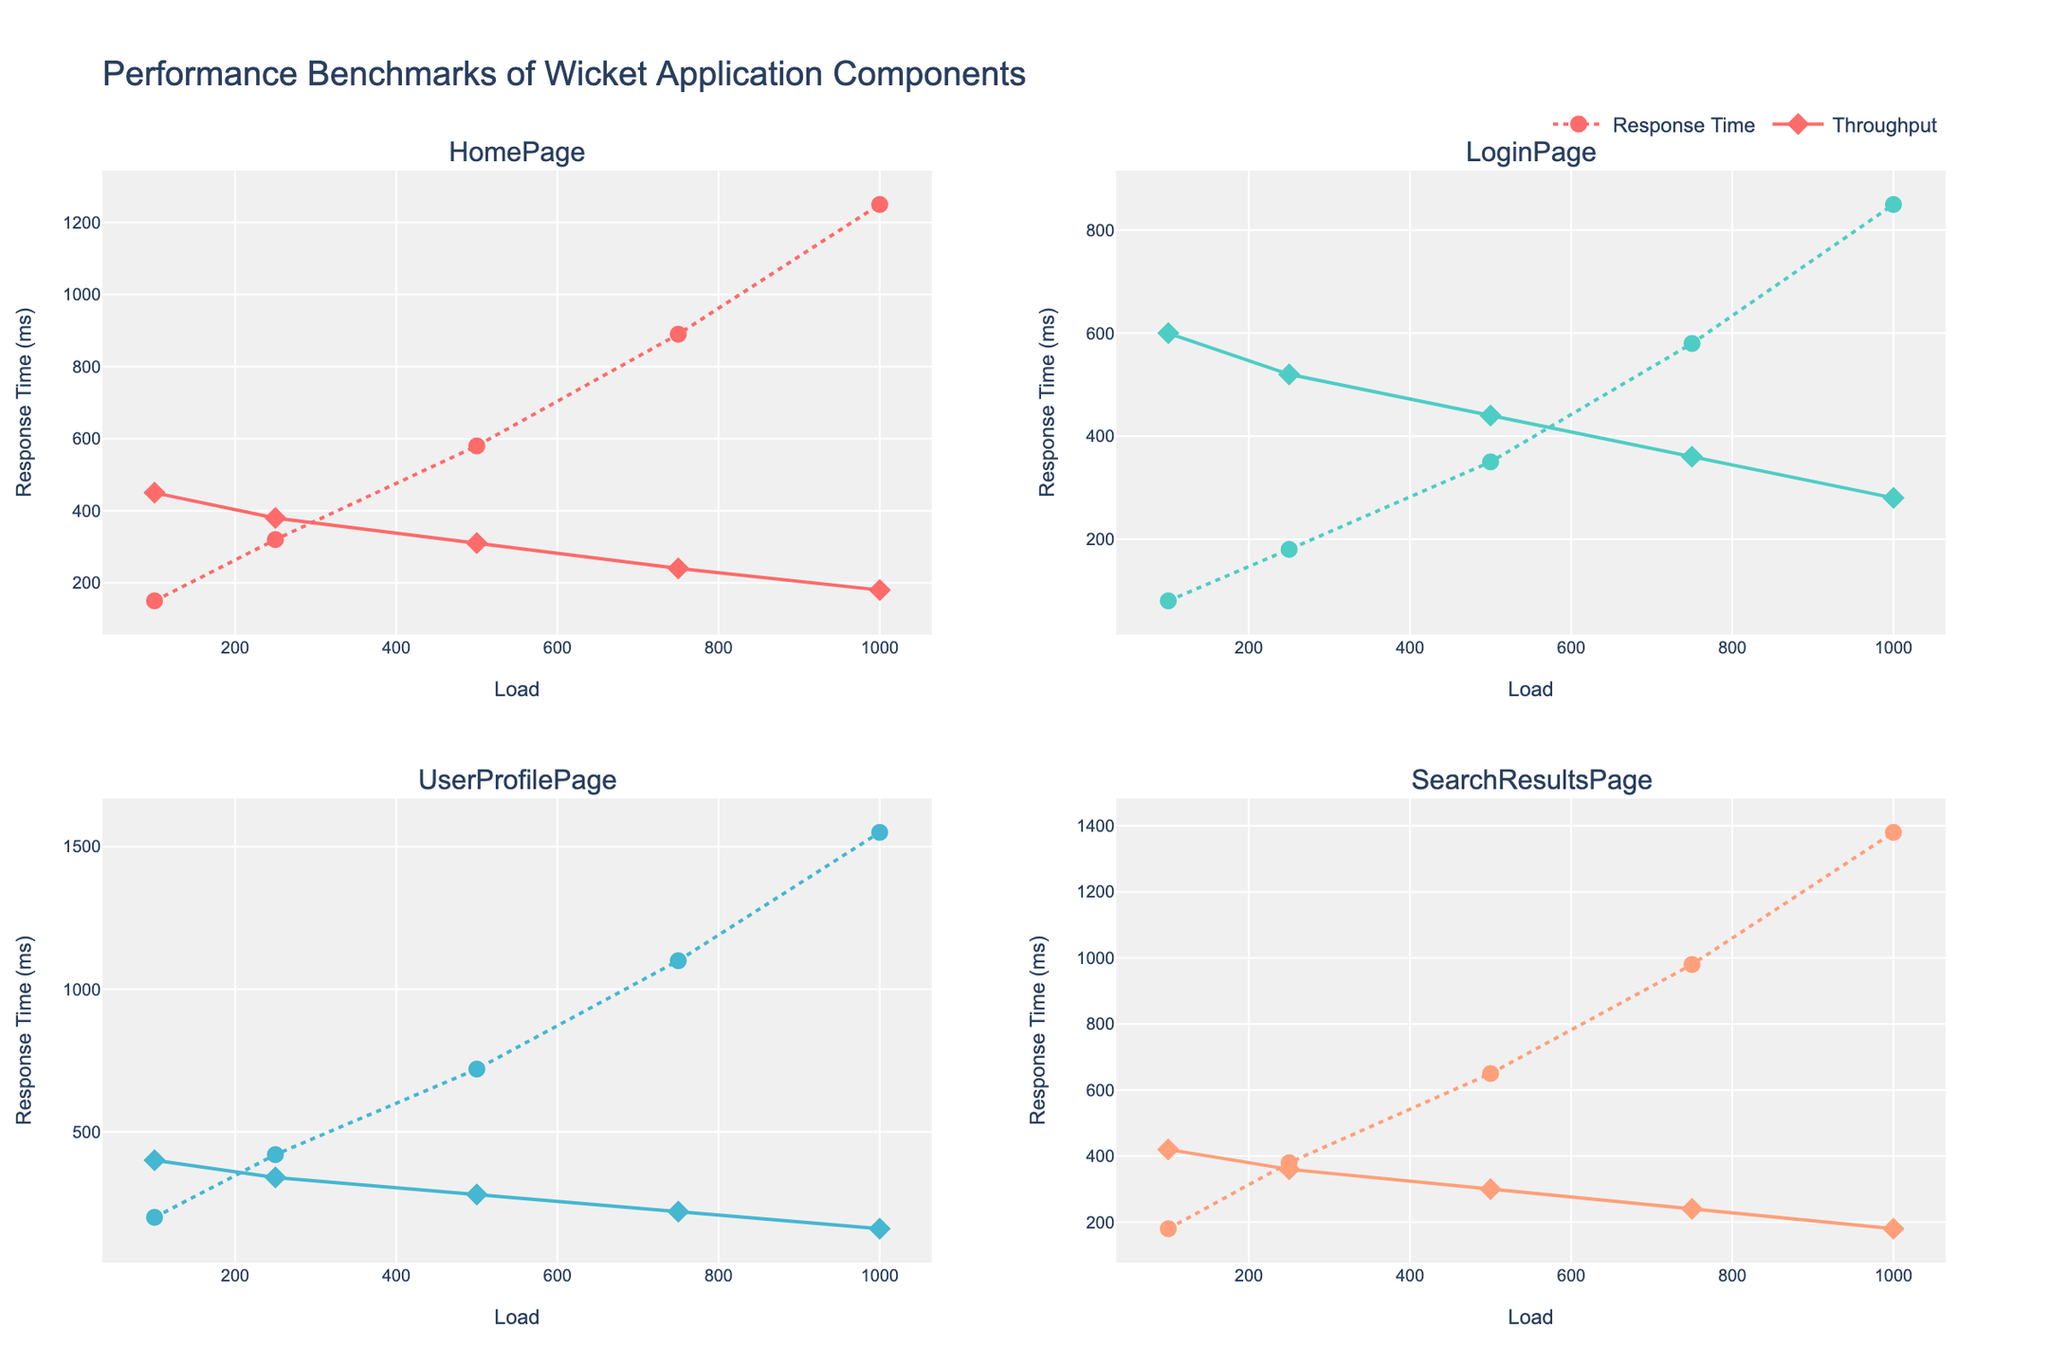What is the title of the figure? The title is displayed at the top of the figure in a larger font and reads "Impact of Monetary Policy on Inflation Rates in Eurozone Countries".
Answer: Impact of Monetary Policy on Inflation Rates in Eurozone Countries Which country had the highest inflation rate before the policy change? The bar chart under the "Inflation Rate Before" subplot shows each country's bar height. Greece has the tallest bar, indicating the highest inflation rate before the policy change.
Answer: Greece By how much did the inflation rate decrease in Germany after the policy change? In the "Inflation Rate Before" subplot, Germany's rate is 1.8%. In the "Inflation Rate After" subplot, it is 1.2%. The decrease is 1.8 - 1.2 = 0.6%.
Answer: 0.6% Which country experienced the least change in their inflation rate after the policy change? Calculate the difference between the "Before" and "After" values for each country. Belgium's rate changed from 2.2% to 1.8%, which is a change of 0.4%, the smallest among all countries.
Answer: Belgium How many countries had their inflation rates reduced to below 1.5% after the policy change? Check the "Inflation Rate After" subplot and count the countries with bars less than 1.5%. The countries are Germany, Netherlands, and Ireland.
Answer: 3 What is the overall average inflation rate after the policy change across all listed countries? Sum all inflation rates after the policy change and divide by the number of countries. (1.2 + 1.6 + 1.9 + 1.7 + 1.4 + 1.8 + 1.5 + 2.4 + 1.8 + 1.3) / 10 equals 1.66%.
Answer: 1.66% Which country had the smallest absolute decrease in inflation rate? Calculate the absolute differences between "Before" and "After" rates for all countries. Belgium's difference is 2.2% - 1.8% = 0.4%, which is the smallest.
Answer: Belgium How does the inflation rate in France compare before and after the policy change? Check France's bars from both subplots. The "Before" rate is 2.1%, and the "After" rate is 1.6%. France's rate decreased after the policy change.
Answer: Decreased 